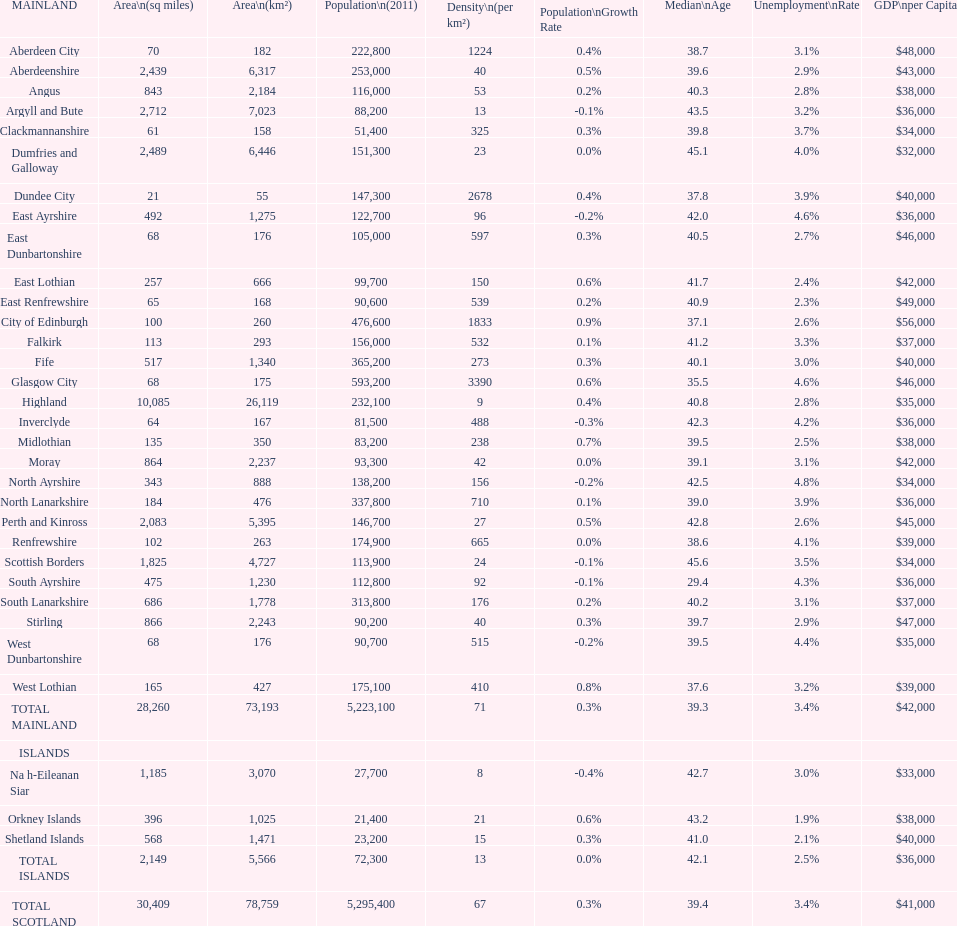Can you parse all the data within this table? {'header': ['MAINLAND', 'Area\\n(sq miles)', 'Area\\n(km²)', 'Population\\n(2011)', 'Density\\n(per km²)', 'Population\\nGrowth Rate', 'Median\\nAge', 'Unemployment\\nRate', 'GDP\\nper Capita'], 'rows': [['Aberdeen City', '70', '182', '222,800', '1224', '0.4%', '38.7', '3.1%', '$48,000'], ['Aberdeenshire', '2,439', '6,317', '253,000', '40', '0.5%', '39.6', '2.9%', '$43,000'], ['Angus', '843', '2,184', '116,000', '53', '0.2%', '40.3', '2.8%', '$38,000'], ['Argyll and Bute', '2,712', '7,023', '88,200', '13', '-0.1%', '43.5', '3.2%', '$36,000'], ['Clackmannanshire', '61', '158', '51,400', '325', '0.3%', '39.8', '3.7%', '$34,000'], ['Dumfries and Galloway', '2,489', '6,446', '151,300', '23', '0.0%', '45.1', '4.0%', '$32,000'], ['Dundee City', '21', '55', '147,300', '2678', '0.4%', '37.8', '3.9%', '$40,000'], ['East Ayrshire', '492', '1,275', '122,700', '96', '-0.2%', '42.0', '4.6%', '$36,000'], ['East Dunbartonshire', '68', '176', '105,000', '597', '0.3%', '40.5', '2.7%', '$46,000'], ['East Lothian', '257', '666', '99,700', '150', '0.6%', '41.7', '2.4%', '$42,000'], ['East Renfrewshire', '65', '168', '90,600', '539', '0.2%', '40.9', '2.3%', '$49,000'], ['City of Edinburgh', '100', '260', '476,600', '1833', '0.9%', '37.1', '2.6%', '$56,000'], ['Falkirk', '113', '293', '156,000', '532', '0.1%', '41.2', '3.3%', '$37,000'], ['Fife', '517', '1,340', '365,200', '273', '0.3%', '40.1', '3.0%', '$40,000'], ['Glasgow City', '68', '175', '593,200', '3390', '0.6%', '35.5', '4.6%', '$46,000'], ['Highland', '10,085', '26,119', '232,100', '9', '0.4%', '40.8', '2.8%', '$35,000'], ['Inverclyde', '64', '167', '81,500', '488', '-0.3%', '42.3', '4.2%', '$36,000'], ['Midlothian', '135', '350', '83,200', '238', '0.7%', '39.5', '2.5%', '$38,000'], ['Moray', '864', '2,237', '93,300', '42', '0.0%', '39.1', '3.1%', '$42,000'], ['North Ayrshire', '343', '888', '138,200', '156', '-0.2%', '42.5', '4.8%', '$34,000'], ['North Lanarkshire', '184', '476', '337,800', '710', '0.1%', '39.0', '3.9%', '$36,000'], ['Perth and Kinross', '2,083', '5,395', '146,700', '27', '0.5%', '42.8', '2.6%', '$45,000'], ['Renfrewshire', '102', '263', '174,900', '665', '0.0%', '38.6', '4.1%', '$39,000'], ['Scottish Borders', '1,825', '4,727', '113,900', '24', '-0.1%', '45.6', '3.5%', '$34,000'], ['South Ayrshire', '475', '1,230', '112,800', '92', '-0.1%', '29.4', '4.3%', '$36,000'], ['South Lanarkshire', '686', '1,778', '313,800', '176', '0.2%', '40.2', '3.1%', '$37,000'], ['Stirling', '866', '2,243', '90,200', '40', '0.3%', '39.7', '2.9%', '$47,000'], ['West Dunbartonshire', '68', '176', '90,700', '515', '-0.2%', '39.5', '4.4%', '$35,000'], ['West Lothian', '165', '427', '175,100', '410', '0.8%', '37.6', '3.2%', '$39,000'], ['TOTAL MAINLAND', '28,260', '73,193', '5,223,100', '71', '0.3%', '39.3', '3.4%', '$42,000'], ['ISLANDS', '', '', '', '', '', '', '', ''], ['Na h-Eileanan Siar', '1,185', '3,070', '27,700', '8', '-0.4%', '42.7', '3.0%', '$33,000'], ['Orkney Islands', '396', '1,025', '21,400', '21', '0.6%', '43.2', '1.9%', '$38,000'], ['Shetland Islands', '568', '1,471', '23,200', '15', '0.3%', '41.0', '2.1%', '$40,000'], ['TOTAL ISLANDS', '2,149', '5,566', '72,300', '13', '0.0%', '42.1', '2.5%', '$36,000'], ['TOTAL SCOTLAND', '30,409', '78,759', '5,295,400', '67', '0.3%', '39.4', '3.4%', '$41,000']]} Which specific subdivision surpasses argyll and bute in terms of area? Highland. 